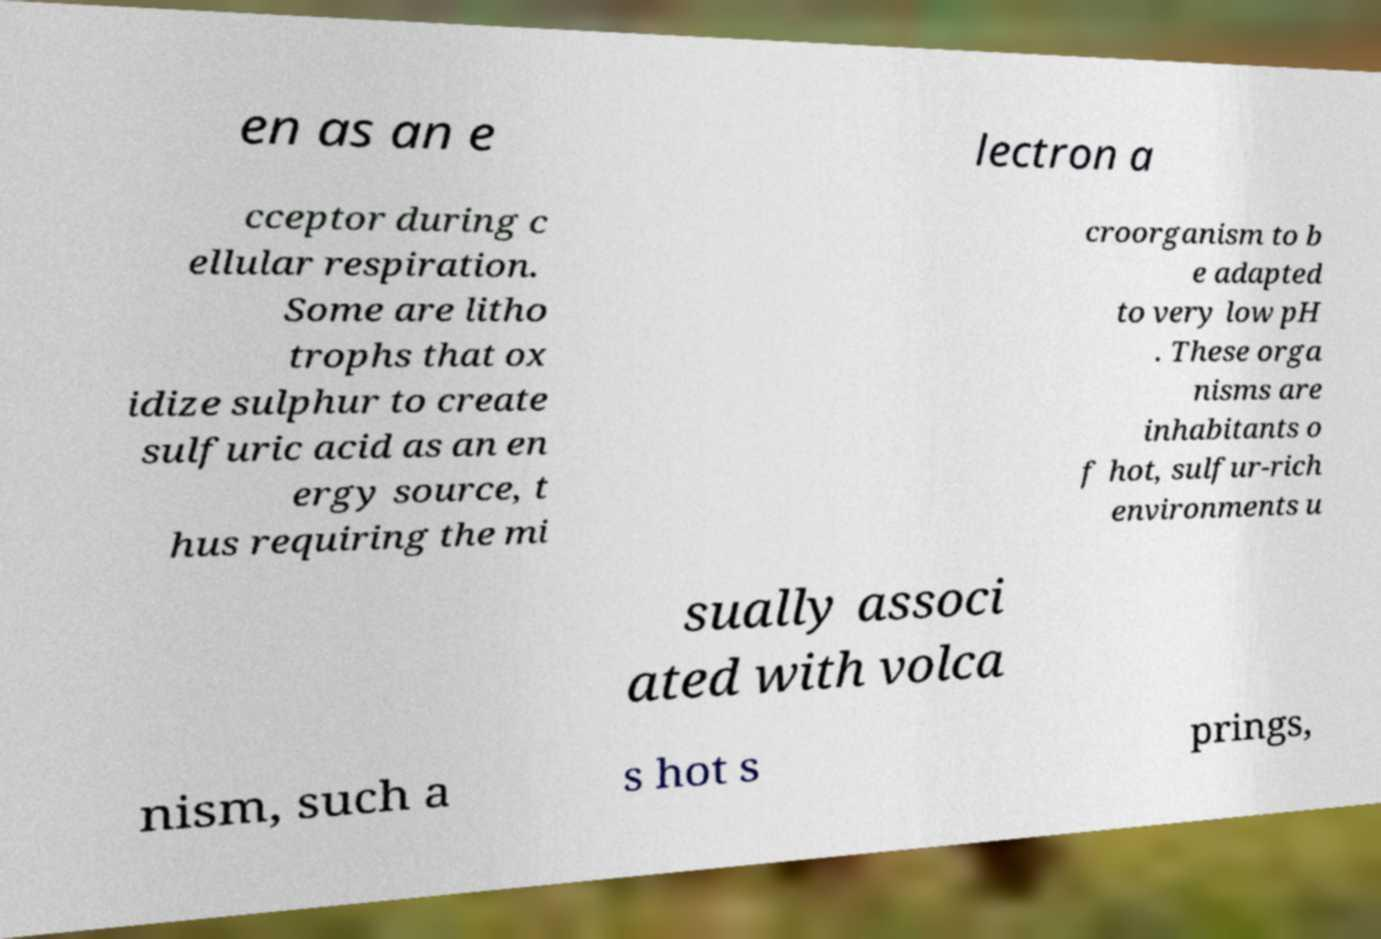Can you accurately transcribe the text from the provided image for me? en as an e lectron a cceptor during c ellular respiration. Some are litho trophs that ox idize sulphur to create sulfuric acid as an en ergy source, t hus requiring the mi croorganism to b e adapted to very low pH . These orga nisms are inhabitants o f hot, sulfur-rich environments u sually associ ated with volca nism, such a s hot s prings, 